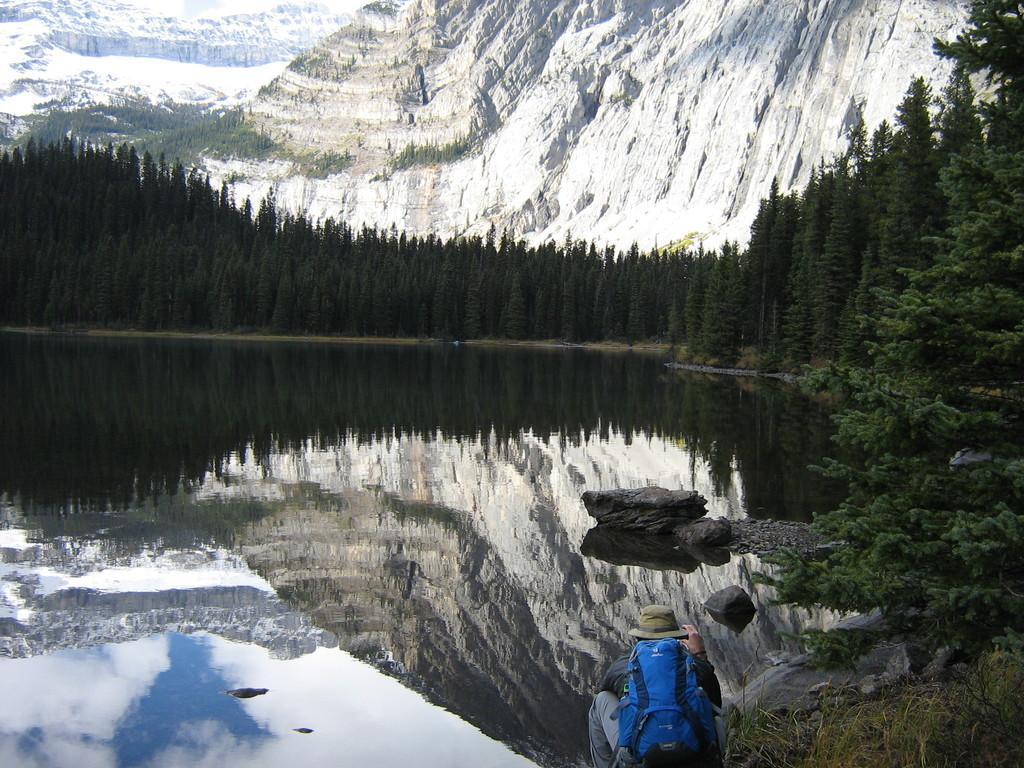In one or two sentences, can you explain what this image depicts? In the foreground of this image, there is a person wearing bag and hat is squatting. In the background, there are trees, water, rocks and the mountains. 